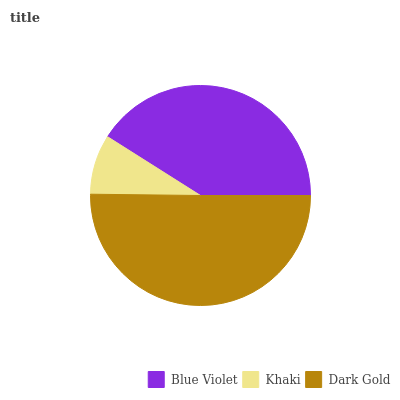Is Khaki the minimum?
Answer yes or no. Yes. Is Dark Gold the maximum?
Answer yes or no. Yes. Is Dark Gold the minimum?
Answer yes or no. No. Is Khaki the maximum?
Answer yes or no. No. Is Dark Gold greater than Khaki?
Answer yes or no. Yes. Is Khaki less than Dark Gold?
Answer yes or no. Yes. Is Khaki greater than Dark Gold?
Answer yes or no. No. Is Dark Gold less than Khaki?
Answer yes or no. No. Is Blue Violet the high median?
Answer yes or no. Yes. Is Blue Violet the low median?
Answer yes or no. Yes. Is Khaki the high median?
Answer yes or no. No. Is Khaki the low median?
Answer yes or no. No. 